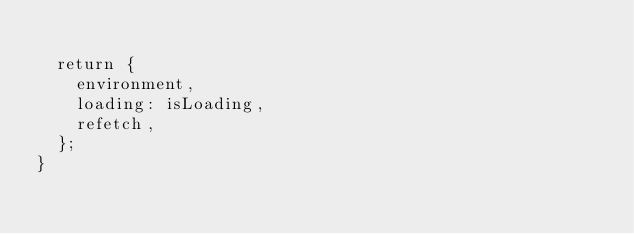Convert code to text. <code><loc_0><loc_0><loc_500><loc_500><_TypeScript_>
  return {
    environment,
    loading: isLoading,
    refetch,
  };
}
</code> 